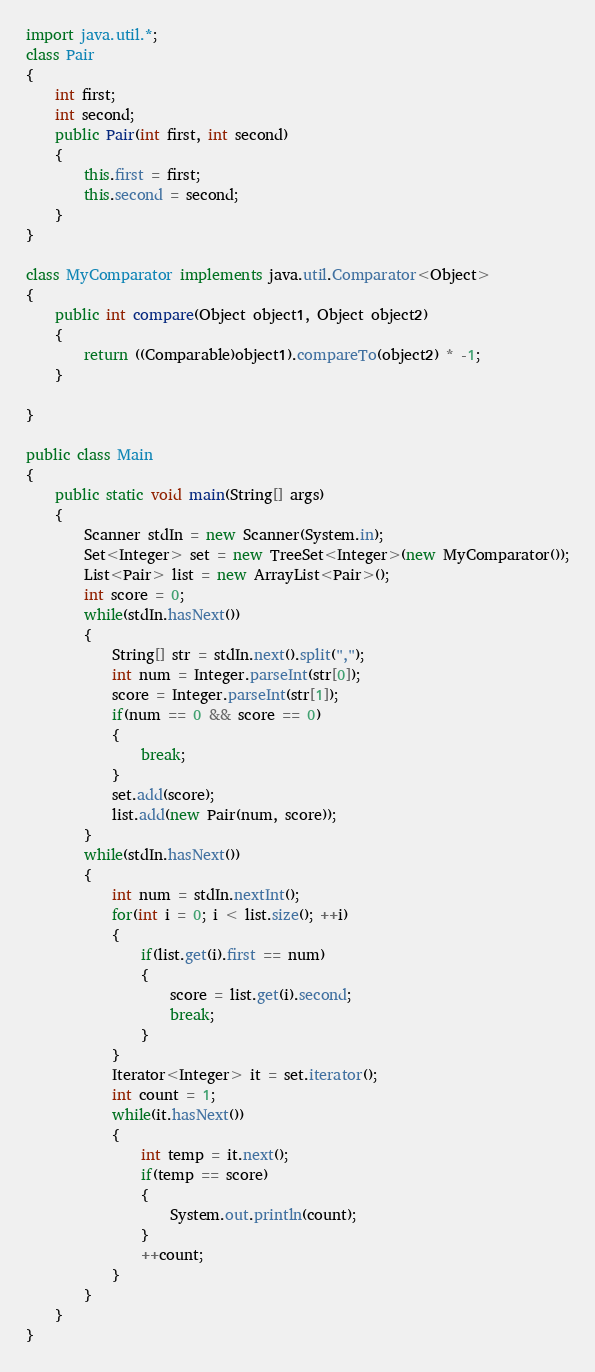<code> <loc_0><loc_0><loc_500><loc_500><_Java_>import java.util.*;
class Pair
{
	int first;
	int second;
	public Pair(int first, int second)
	{
		this.first = first;
		this.second = second;
	}
}

class MyComparator implements java.util.Comparator<Object>
{
	public int compare(Object object1, Object object2)
	{
        return ((Comparable)object1).compareTo(object2) * -1;
    }

}

public class Main 
{
	public static void main(String[] args) 
	{
		Scanner stdIn = new Scanner(System.in);
		Set<Integer> set = new TreeSet<Integer>(new MyComparator());
		List<Pair> list = new ArrayList<Pair>();
		int score = 0;
		while(stdIn.hasNext())
		{
			String[] str = stdIn.next().split(",");
			int num = Integer.parseInt(str[0]);
			score = Integer.parseInt(str[1]);
			if(num == 0 && score == 0)
			{
				break;
			}
			set.add(score);
			list.add(new Pair(num, score));
		}
		while(stdIn.hasNext())
		{
			int num = stdIn.nextInt();
			for(int i = 0; i < list.size(); ++i)
			{
				if(list.get(i).first == num)
				{
					score = list.get(i).second;
					break;
				}
			}
			Iterator<Integer> it = set.iterator();
			int count = 1;
			while(it.hasNext())
			{
				int temp = it.next();
				if(temp == score)
				{
					System.out.println(count);
				}
				++count;
			}
		}
	}
}</code> 